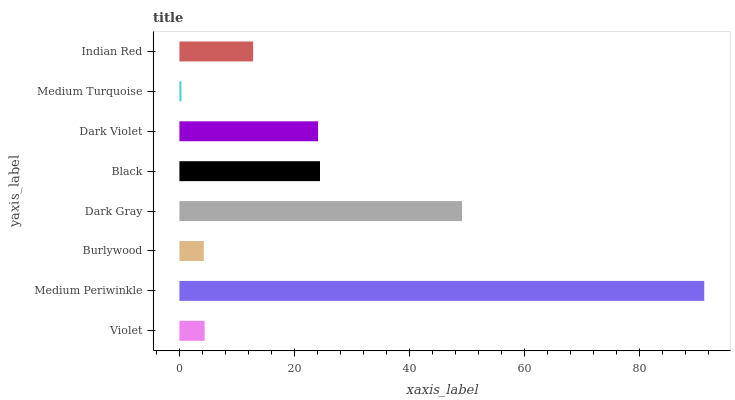Is Medium Turquoise the minimum?
Answer yes or no. Yes. Is Medium Periwinkle the maximum?
Answer yes or no. Yes. Is Burlywood the minimum?
Answer yes or no. No. Is Burlywood the maximum?
Answer yes or no. No. Is Medium Periwinkle greater than Burlywood?
Answer yes or no. Yes. Is Burlywood less than Medium Periwinkle?
Answer yes or no. Yes. Is Burlywood greater than Medium Periwinkle?
Answer yes or no. No. Is Medium Periwinkle less than Burlywood?
Answer yes or no. No. Is Dark Violet the high median?
Answer yes or no. Yes. Is Indian Red the low median?
Answer yes or no. Yes. Is Burlywood the high median?
Answer yes or no. No. Is Medium Periwinkle the low median?
Answer yes or no. No. 